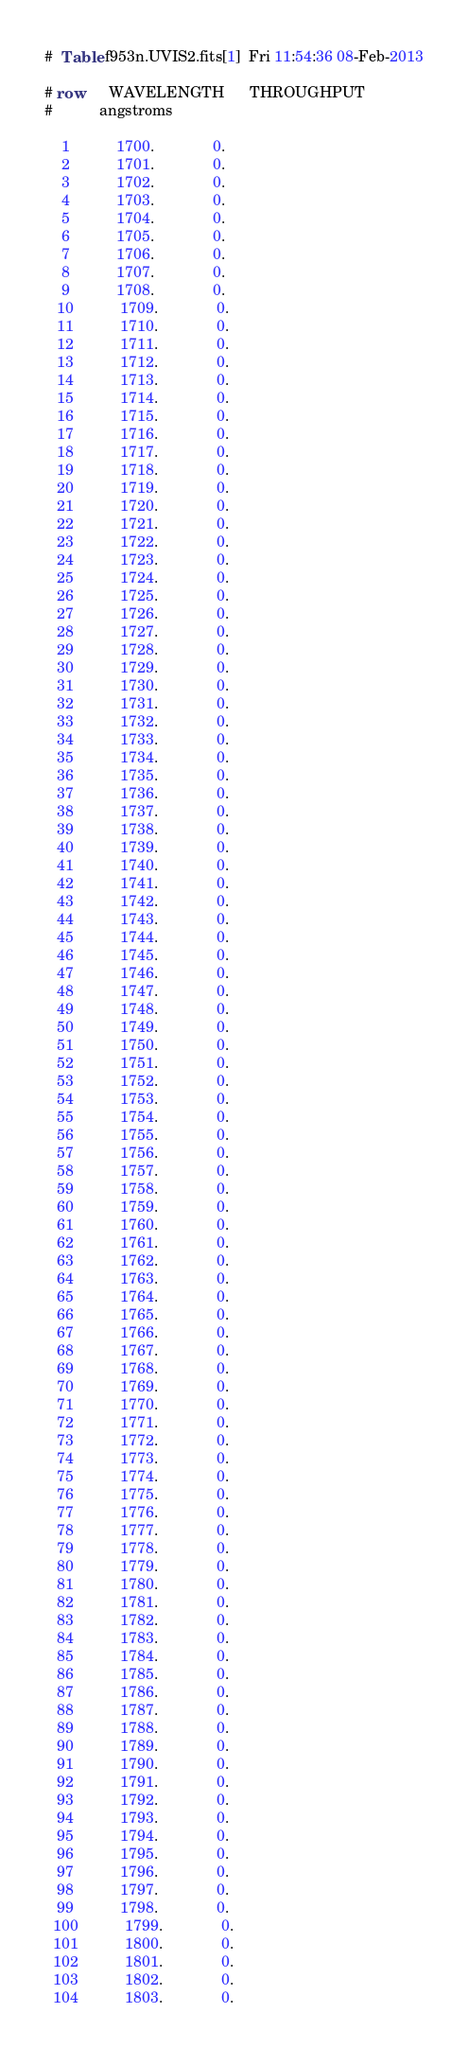<code> <loc_0><loc_0><loc_500><loc_500><_SQL_>#  Table f953n.UVIS2.fits[1]  Fri 11:54:36 08-Feb-2013

# row      WAVELENGTH      THROUGHPUT
#           angstroms                

    1           1700.              0.
    2           1701.              0.
    3           1702.              0.
    4           1703.              0.
    5           1704.              0.
    6           1705.              0.
    7           1706.              0.
    8           1707.              0.
    9           1708.              0.
   10           1709.              0.
   11           1710.              0.
   12           1711.              0.
   13           1712.              0.
   14           1713.              0.
   15           1714.              0.
   16           1715.              0.
   17           1716.              0.
   18           1717.              0.
   19           1718.              0.
   20           1719.              0.
   21           1720.              0.
   22           1721.              0.
   23           1722.              0.
   24           1723.              0.
   25           1724.              0.
   26           1725.              0.
   27           1726.              0.
   28           1727.              0.
   29           1728.              0.
   30           1729.              0.
   31           1730.              0.
   32           1731.              0.
   33           1732.              0.
   34           1733.              0.
   35           1734.              0.
   36           1735.              0.
   37           1736.              0.
   38           1737.              0.
   39           1738.              0.
   40           1739.              0.
   41           1740.              0.
   42           1741.              0.
   43           1742.              0.
   44           1743.              0.
   45           1744.              0.
   46           1745.              0.
   47           1746.              0.
   48           1747.              0.
   49           1748.              0.
   50           1749.              0.
   51           1750.              0.
   52           1751.              0.
   53           1752.              0.
   54           1753.              0.
   55           1754.              0.
   56           1755.              0.
   57           1756.              0.
   58           1757.              0.
   59           1758.              0.
   60           1759.              0.
   61           1760.              0.
   62           1761.              0.
   63           1762.              0.
   64           1763.              0.
   65           1764.              0.
   66           1765.              0.
   67           1766.              0.
   68           1767.              0.
   69           1768.              0.
   70           1769.              0.
   71           1770.              0.
   72           1771.              0.
   73           1772.              0.
   74           1773.              0.
   75           1774.              0.
   76           1775.              0.
   77           1776.              0.
   78           1777.              0.
   79           1778.              0.
   80           1779.              0.
   81           1780.              0.
   82           1781.              0.
   83           1782.              0.
   84           1783.              0.
   85           1784.              0.
   86           1785.              0.
   87           1786.              0.
   88           1787.              0.
   89           1788.              0.
   90           1789.              0.
   91           1790.              0.
   92           1791.              0.
   93           1792.              0.
   94           1793.              0.
   95           1794.              0.
   96           1795.              0.
   97           1796.              0.
   98           1797.              0.
   99           1798.              0.
  100           1799.              0.
  101           1800.              0.
  102           1801.              0.
  103           1802.              0.
  104           1803.              0.</code> 